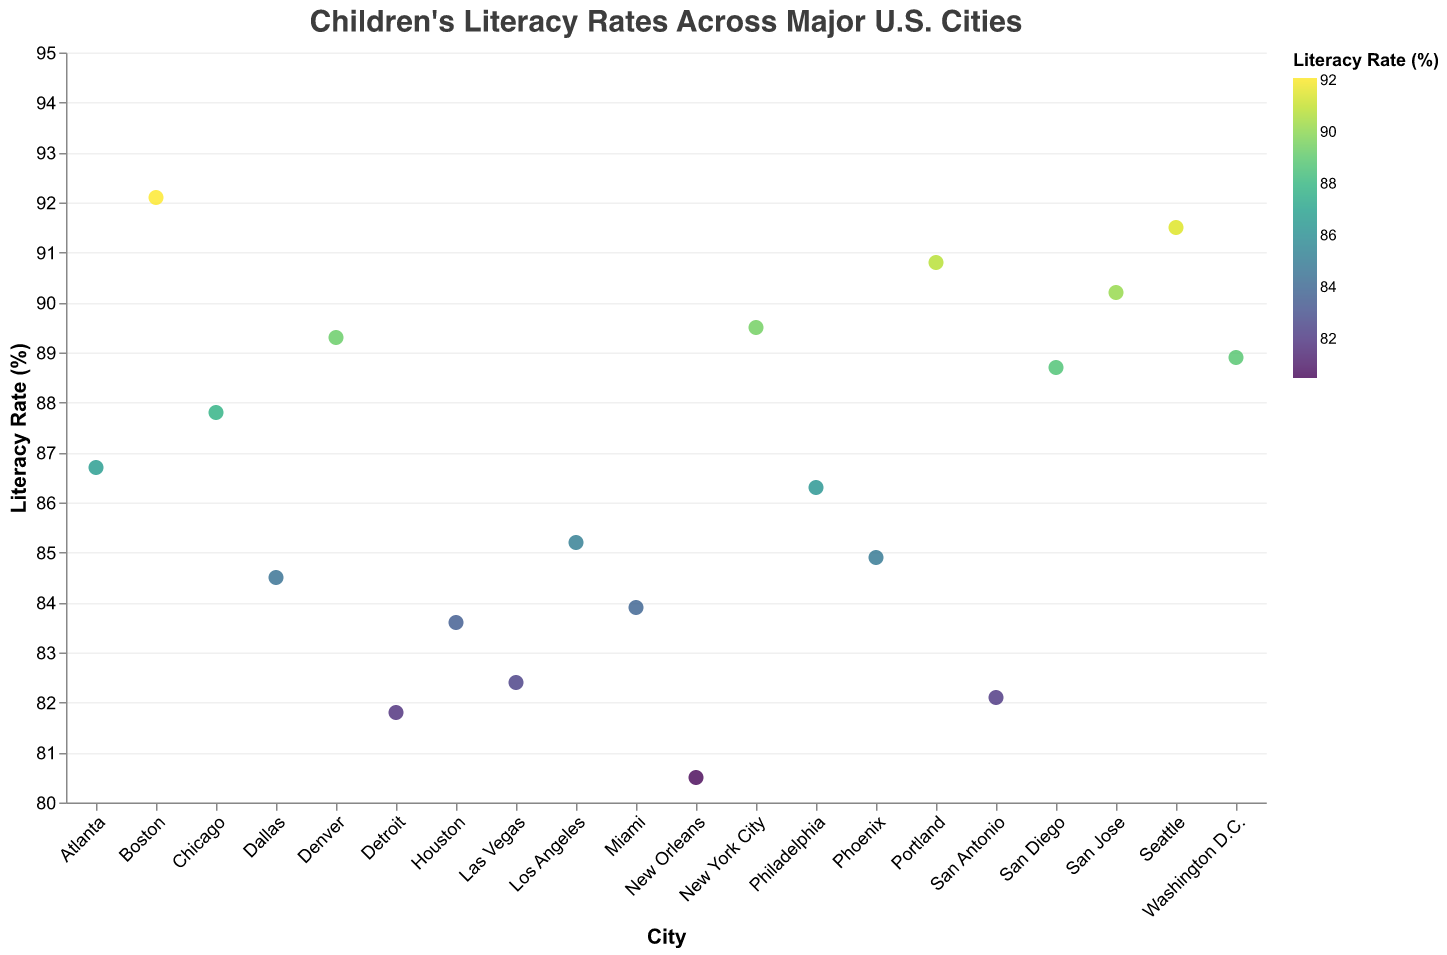What is the title of the figure? The title of the figure is typically displayed at the top of the chart. Here, it reads "Children's Literacy Rates Across Major U.S. Cities."
Answer: Children's Literacy Rates Across Major U.S. Cities How many cities are shown in the figure? Count the number of data points (circles) in the plot. Each point represents a different city. By counting, we find there are 20 cities.
Answer: 20 Which city has the highest literacy rate? Look for the data point that reaches the highest value on the y-axis labeled "Literacy Rate (%)." The highest point corresponds to Boston with a literacy rate of 92.1%.
Answer: Boston What is the literacy rate of Miami? Find the data point labeled "Miami" on the x-axis and check its position on the y-axis. Miami's literacy rate is at 83.9%.
Answer: 83.9% Which city has the lowest literacy rate? Identify the lowest point on the y-axis labeled "Literacy Rate (%)." This corresponds to New Orleans with a literacy rate of 80.5%.
Answer: New Orleans Compare the literacy rates of New York City and Los Angeles. Which city has a higher rate and by how much? Find and compare the data points for both New York City (89.5%) and Los Angeles (85.2%). Subtract the literacy rate of Los Angeles from New York City. 89.5% - 85.2% = 4.3%.
Answer: New York City by 4.3% What is the average literacy rate of all the cities displayed? Sum all the literacy rates and divide by the number of cities. The rates sum to 1742.6, and dividing by 20 gives an average of 87.13%.
Answer: 87.13% Which cities have literacy rates above 90%? List them. Identify the data points on the plot above the 90% mark on the y-axis. The cities are San Jose (90.2%), Seattle (91.5%), Portland (90.8%), and Boston (92.1%).
Answer: San Jose, Seattle, Portland, Boston How much higher is Boston's literacy rate compared to the national average calculated from the cities displayed? Calculate the difference between Boston's literacy rate (92.1%) and the average literacy rate (87.13%). 92.1% - 87.13% = 4.97%.
Answer: 4.97% Among the cities with the lowest literacy rates, which one is just above New Orleans? Find the data point immediately above New Orleans (80.5%). The next lowest point belongs to Detroit with a literacy rate of 81.8%.
Answer: Detroit 